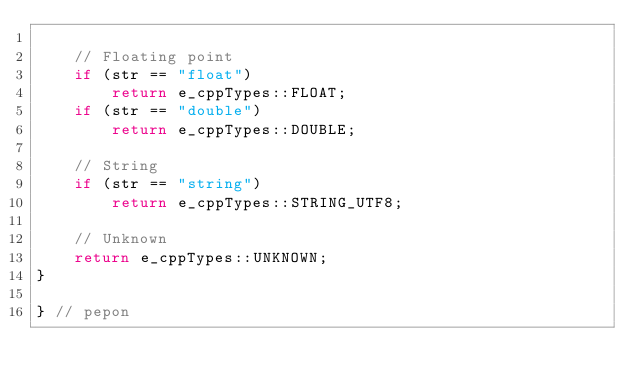Convert code to text. <code><loc_0><loc_0><loc_500><loc_500><_C++_>
    // Floating point
    if (str == "float")
        return e_cppTypes::FLOAT;
    if (str == "double")
        return e_cppTypes::DOUBLE;

    // String
    if (str == "string")
        return e_cppTypes::STRING_UTF8;

    // Unknown
    return e_cppTypes::UNKNOWN;
}

} // pepon
</code> 